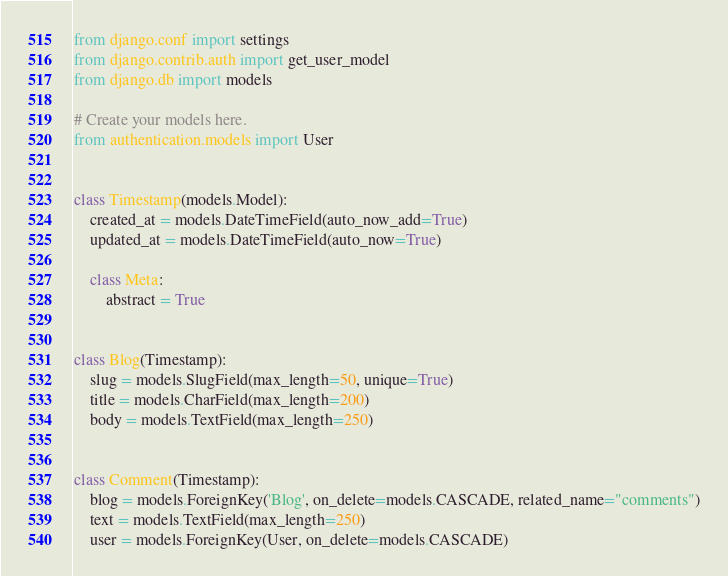<code> <loc_0><loc_0><loc_500><loc_500><_Python_>from django.conf import settings
from django.contrib.auth import get_user_model
from django.db import models

# Create your models here.
from authentication.models import User


class Timestamp(models.Model):
    created_at = models.DateTimeField(auto_now_add=True)
    updated_at = models.DateTimeField(auto_now=True)

    class Meta:
        abstract = True


class Blog(Timestamp):
    slug = models.SlugField(max_length=50, unique=True)
    title = models.CharField(max_length=200)
    body = models.TextField(max_length=250)


class Comment(Timestamp):
    blog = models.ForeignKey('Blog', on_delete=models.CASCADE, related_name="comments")
    text = models.TextField(max_length=250)
    user = models.ForeignKey(User, on_delete=models.CASCADE)
</code> 